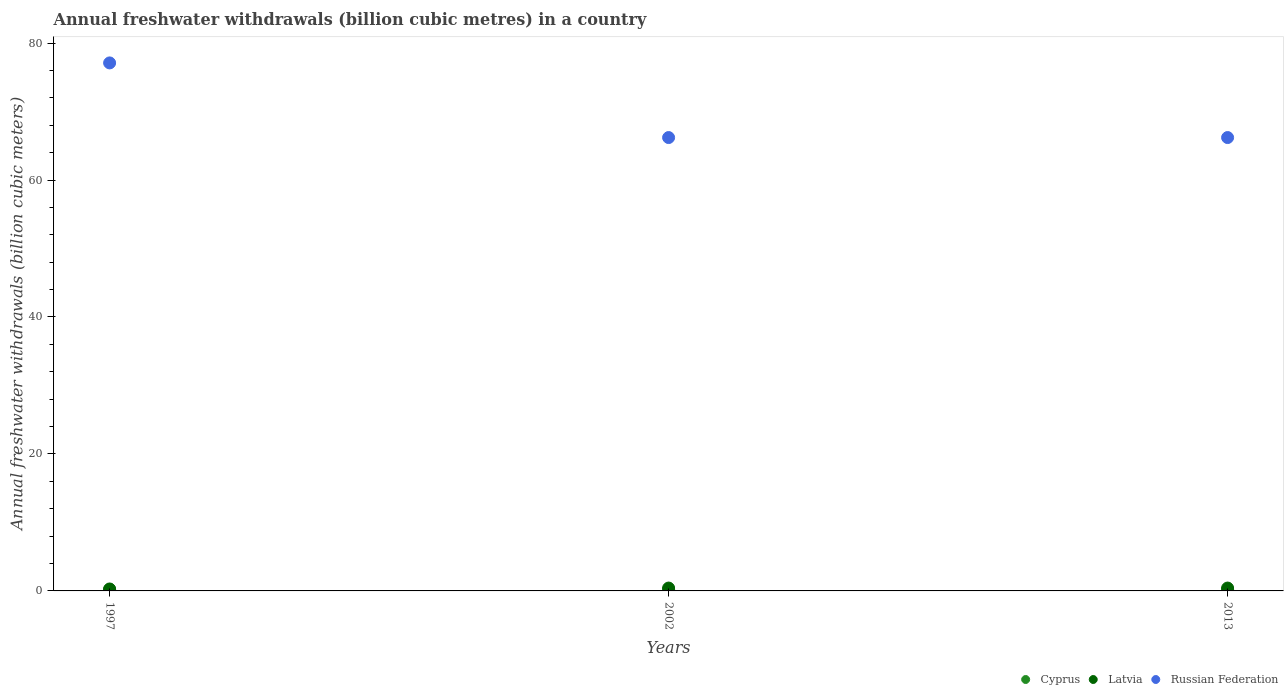How many different coloured dotlines are there?
Make the answer very short. 3. Is the number of dotlines equal to the number of legend labels?
Your response must be concise. Yes. What is the annual freshwater withdrawals in Russian Federation in 2002?
Ensure brevity in your answer.  66.2. Across all years, what is the maximum annual freshwater withdrawals in Cyprus?
Your response must be concise. 0.21. Across all years, what is the minimum annual freshwater withdrawals in Cyprus?
Your answer should be very brief. 0.18. In which year was the annual freshwater withdrawals in Cyprus maximum?
Offer a very short reply. 1997. What is the total annual freshwater withdrawals in Cyprus in the graph?
Your answer should be very brief. 0.61. What is the difference between the annual freshwater withdrawals in Latvia in 1997 and that in 2002?
Keep it short and to the point. -0.13. What is the difference between the annual freshwater withdrawals in Russian Federation in 2002 and the annual freshwater withdrawals in Latvia in 2013?
Offer a very short reply. 65.78. What is the average annual freshwater withdrawals in Latvia per year?
Offer a terse response. 0.37. In the year 1997, what is the difference between the annual freshwater withdrawals in Latvia and annual freshwater withdrawals in Russian Federation?
Your answer should be compact. -76.81. In how many years, is the annual freshwater withdrawals in Latvia greater than 44 billion cubic meters?
Your answer should be compact. 0. What is the ratio of the annual freshwater withdrawals in Latvia in 1997 to that in 2013?
Make the answer very short. 0.68. Is the annual freshwater withdrawals in Latvia in 2002 less than that in 2013?
Make the answer very short. No. Is the difference between the annual freshwater withdrawals in Latvia in 1997 and 2002 greater than the difference between the annual freshwater withdrawals in Russian Federation in 1997 and 2002?
Keep it short and to the point. No. What is the difference between the highest and the second highest annual freshwater withdrawals in Russian Federation?
Provide a succinct answer. 10.9. What is the difference between the highest and the lowest annual freshwater withdrawals in Cyprus?
Your answer should be compact. 0.03. In how many years, is the annual freshwater withdrawals in Latvia greater than the average annual freshwater withdrawals in Latvia taken over all years?
Offer a very short reply. 2. Does the annual freshwater withdrawals in Cyprus monotonically increase over the years?
Ensure brevity in your answer.  No. Are the values on the major ticks of Y-axis written in scientific E-notation?
Give a very brief answer. No. Does the graph contain grids?
Provide a succinct answer. No. What is the title of the graph?
Your response must be concise. Annual freshwater withdrawals (billion cubic metres) in a country. Does "Cayman Islands" appear as one of the legend labels in the graph?
Provide a succinct answer. No. What is the label or title of the Y-axis?
Provide a short and direct response. Annual freshwater withdrawals (billion cubic meters). What is the Annual freshwater withdrawals (billion cubic meters) of Cyprus in 1997?
Your response must be concise. 0.21. What is the Annual freshwater withdrawals (billion cubic meters) of Latvia in 1997?
Give a very brief answer. 0.28. What is the Annual freshwater withdrawals (billion cubic meters) of Russian Federation in 1997?
Make the answer very short. 77.1. What is the Annual freshwater withdrawals (billion cubic meters) in Cyprus in 2002?
Make the answer very short. 0.21. What is the Annual freshwater withdrawals (billion cubic meters) of Latvia in 2002?
Offer a terse response. 0.42. What is the Annual freshwater withdrawals (billion cubic meters) of Russian Federation in 2002?
Your answer should be compact. 66.2. What is the Annual freshwater withdrawals (billion cubic meters) in Cyprus in 2013?
Offer a terse response. 0.18. What is the Annual freshwater withdrawals (billion cubic meters) in Latvia in 2013?
Your response must be concise. 0.42. What is the Annual freshwater withdrawals (billion cubic meters) of Russian Federation in 2013?
Offer a terse response. 66.2. Across all years, what is the maximum Annual freshwater withdrawals (billion cubic meters) of Cyprus?
Your response must be concise. 0.21. Across all years, what is the maximum Annual freshwater withdrawals (billion cubic meters) of Latvia?
Keep it short and to the point. 0.42. Across all years, what is the maximum Annual freshwater withdrawals (billion cubic meters) in Russian Federation?
Your answer should be compact. 77.1. Across all years, what is the minimum Annual freshwater withdrawals (billion cubic meters) of Cyprus?
Offer a terse response. 0.18. Across all years, what is the minimum Annual freshwater withdrawals (billion cubic meters) of Latvia?
Keep it short and to the point. 0.28. Across all years, what is the minimum Annual freshwater withdrawals (billion cubic meters) in Russian Federation?
Your answer should be compact. 66.2. What is the total Annual freshwater withdrawals (billion cubic meters) in Cyprus in the graph?
Provide a short and direct response. 0.61. What is the total Annual freshwater withdrawals (billion cubic meters) of Latvia in the graph?
Your answer should be very brief. 1.12. What is the total Annual freshwater withdrawals (billion cubic meters) in Russian Federation in the graph?
Offer a terse response. 209.5. What is the difference between the Annual freshwater withdrawals (billion cubic meters) in Latvia in 1997 and that in 2002?
Ensure brevity in your answer.  -0.13. What is the difference between the Annual freshwater withdrawals (billion cubic meters) in Russian Federation in 1997 and that in 2002?
Provide a short and direct response. 10.9. What is the difference between the Annual freshwater withdrawals (billion cubic meters) in Cyprus in 1997 and that in 2013?
Ensure brevity in your answer.  0.03. What is the difference between the Annual freshwater withdrawals (billion cubic meters) of Latvia in 1997 and that in 2013?
Offer a terse response. -0.13. What is the difference between the Annual freshwater withdrawals (billion cubic meters) in Cyprus in 2002 and that in 2013?
Your answer should be compact. 0.03. What is the difference between the Annual freshwater withdrawals (billion cubic meters) in Latvia in 2002 and that in 2013?
Your response must be concise. 0. What is the difference between the Annual freshwater withdrawals (billion cubic meters) of Cyprus in 1997 and the Annual freshwater withdrawals (billion cubic meters) of Latvia in 2002?
Make the answer very short. -0.21. What is the difference between the Annual freshwater withdrawals (billion cubic meters) of Cyprus in 1997 and the Annual freshwater withdrawals (billion cubic meters) of Russian Federation in 2002?
Keep it short and to the point. -65.99. What is the difference between the Annual freshwater withdrawals (billion cubic meters) in Latvia in 1997 and the Annual freshwater withdrawals (billion cubic meters) in Russian Federation in 2002?
Your answer should be compact. -65.92. What is the difference between the Annual freshwater withdrawals (billion cubic meters) in Cyprus in 1997 and the Annual freshwater withdrawals (billion cubic meters) in Latvia in 2013?
Give a very brief answer. -0.21. What is the difference between the Annual freshwater withdrawals (billion cubic meters) of Cyprus in 1997 and the Annual freshwater withdrawals (billion cubic meters) of Russian Federation in 2013?
Your answer should be compact. -65.99. What is the difference between the Annual freshwater withdrawals (billion cubic meters) of Latvia in 1997 and the Annual freshwater withdrawals (billion cubic meters) of Russian Federation in 2013?
Your answer should be very brief. -65.92. What is the difference between the Annual freshwater withdrawals (billion cubic meters) of Cyprus in 2002 and the Annual freshwater withdrawals (billion cubic meters) of Latvia in 2013?
Provide a succinct answer. -0.21. What is the difference between the Annual freshwater withdrawals (billion cubic meters) of Cyprus in 2002 and the Annual freshwater withdrawals (billion cubic meters) of Russian Federation in 2013?
Provide a succinct answer. -65.99. What is the difference between the Annual freshwater withdrawals (billion cubic meters) in Latvia in 2002 and the Annual freshwater withdrawals (billion cubic meters) in Russian Federation in 2013?
Offer a terse response. -65.78. What is the average Annual freshwater withdrawals (billion cubic meters) in Cyprus per year?
Ensure brevity in your answer.  0.2. What is the average Annual freshwater withdrawals (billion cubic meters) in Latvia per year?
Give a very brief answer. 0.37. What is the average Annual freshwater withdrawals (billion cubic meters) of Russian Federation per year?
Make the answer very short. 69.83. In the year 1997, what is the difference between the Annual freshwater withdrawals (billion cubic meters) of Cyprus and Annual freshwater withdrawals (billion cubic meters) of Latvia?
Give a very brief answer. -0.07. In the year 1997, what is the difference between the Annual freshwater withdrawals (billion cubic meters) of Cyprus and Annual freshwater withdrawals (billion cubic meters) of Russian Federation?
Ensure brevity in your answer.  -76.89. In the year 1997, what is the difference between the Annual freshwater withdrawals (billion cubic meters) in Latvia and Annual freshwater withdrawals (billion cubic meters) in Russian Federation?
Your answer should be compact. -76.81. In the year 2002, what is the difference between the Annual freshwater withdrawals (billion cubic meters) of Cyprus and Annual freshwater withdrawals (billion cubic meters) of Latvia?
Your answer should be compact. -0.21. In the year 2002, what is the difference between the Annual freshwater withdrawals (billion cubic meters) in Cyprus and Annual freshwater withdrawals (billion cubic meters) in Russian Federation?
Offer a very short reply. -65.99. In the year 2002, what is the difference between the Annual freshwater withdrawals (billion cubic meters) in Latvia and Annual freshwater withdrawals (billion cubic meters) in Russian Federation?
Ensure brevity in your answer.  -65.78. In the year 2013, what is the difference between the Annual freshwater withdrawals (billion cubic meters) in Cyprus and Annual freshwater withdrawals (billion cubic meters) in Latvia?
Your answer should be very brief. -0.23. In the year 2013, what is the difference between the Annual freshwater withdrawals (billion cubic meters) of Cyprus and Annual freshwater withdrawals (billion cubic meters) of Russian Federation?
Make the answer very short. -66.02. In the year 2013, what is the difference between the Annual freshwater withdrawals (billion cubic meters) in Latvia and Annual freshwater withdrawals (billion cubic meters) in Russian Federation?
Give a very brief answer. -65.78. What is the ratio of the Annual freshwater withdrawals (billion cubic meters) of Latvia in 1997 to that in 2002?
Give a very brief answer. 0.68. What is the ratio of the Annual freshwater withdrawals (billion cubic meters) in Russian Federation in 1997 to that in 2002?
Ensure brevity in your answer.  1.16. What is the ratio of the Annual freshwater withdrawals (billion cubic meters) in Cyprus in 1997 to that in 2013?
Keep it short and to the point. 1.15. What is the ratio of the Annual freshwater withdrawals (billion cubic meters) in Latvia in 1997 to that in 2013?
Your response must be concise. 0.68. What is the ratio of the Annual freshwater withdrawals (billion cubic meters) in Russian Federation in 1997 to that in 2013?
Keep it short and to the point. 1.16. What is the ratio of the Annual freshwater withdrawals (billion cubic meters) of Cyprus in 2002 to that in 2013?
Give a very brief answer. 1.14. What is the ratio of the Annual freshwater withdrawals (billion cubic meters) of Latvia in 2002 to that in 2013?
Provide a succinct answer. 1. What is the difference between the highest and the second highest Annual freshwater withdrawals (billion cubic meters) of Cyprus?
Offer a very short reply. 0. What is the difference between the highest and the second highest Annual freshwater withdrawals (billion cubic meters) in Latvia?
Keep it short and to the point. 0. What is the difference between the highest and the second highest Annual freshwater withdrawals (billion cubic meters) of Russian Federation?
Make the answer very short. 10.9. What is the difference between the highest and the lowest Annual freshwater withdrawals (billion cubic meters) in Cyprus?
Make the answer very short. 0.03. What is the difference between the highest and the lowest Annual freshwater withdrawals (billion cubic meters) in Latvia?
Your answer should be very brief. 0.13. 